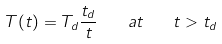Convert formula to latex. <formula><loc_0><loc_0><loc_500><loc_500>T ( t ) = T _ { d } \frac { t _ { d } } { t } \quad a t \quad t > t _ { d }</formula> 